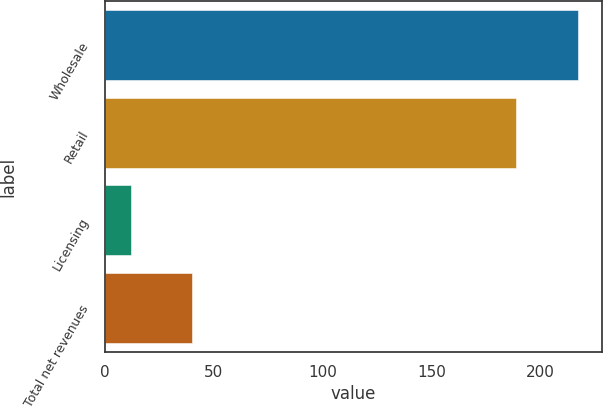Convert chart to OTSL. <chart><loc_0><loc_0><loc_500><loc_500><bar_chart><fcel>Wholesale<fcel>Retail<fcel>Licensing<fcel>Total net revenues<nl><fcel>217.1<fcel>188.9<fcel>11.8<fcel>40<nl></chart> 